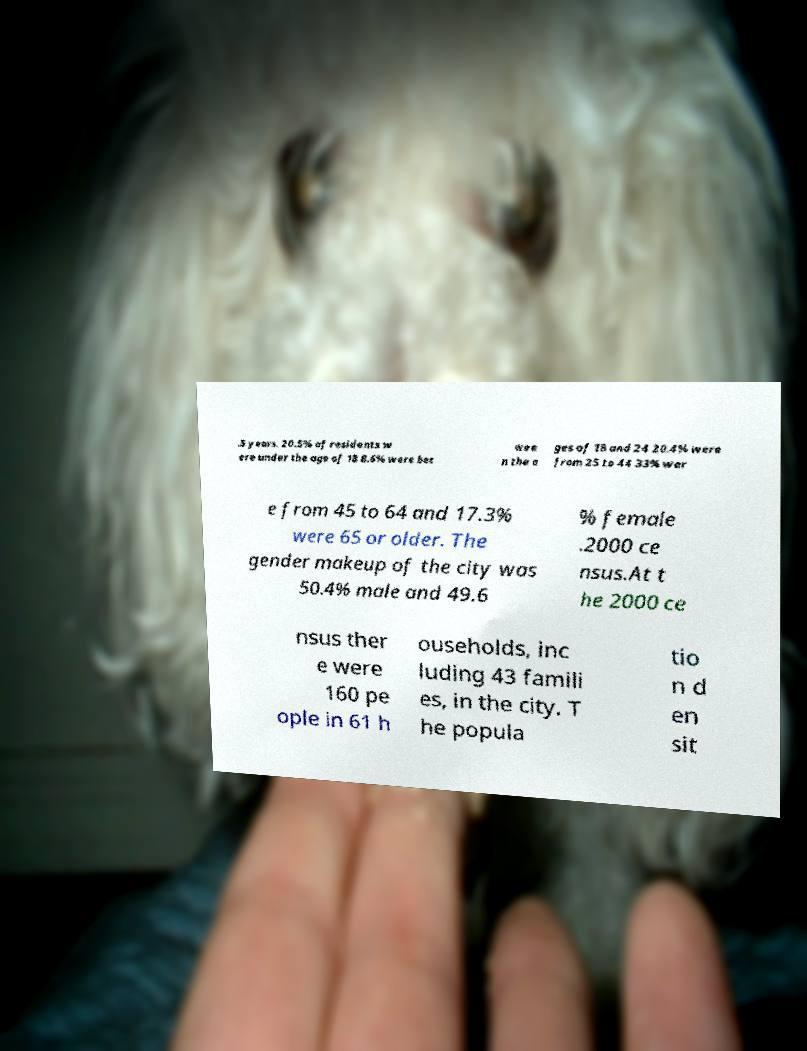Could you assist in decoding the text presented in this image and type it out clearly? .5 years. 20.5% of residents w ere under the age of 18 8.6% were bet wee n the a ges of 18 and 24 20.4% were from 25 to 44 33% wer e from 45 to 64 and 17.3% were 65 or older. The gender makeup of the city was 50.4% male and 49.6 % female .2000 ce nsus.At t he 2000 ce nsus ther e were 160 pe ople in 61 h ouseholds, inc luding 43 famili es, in the city. T he popula tio n d en sit 